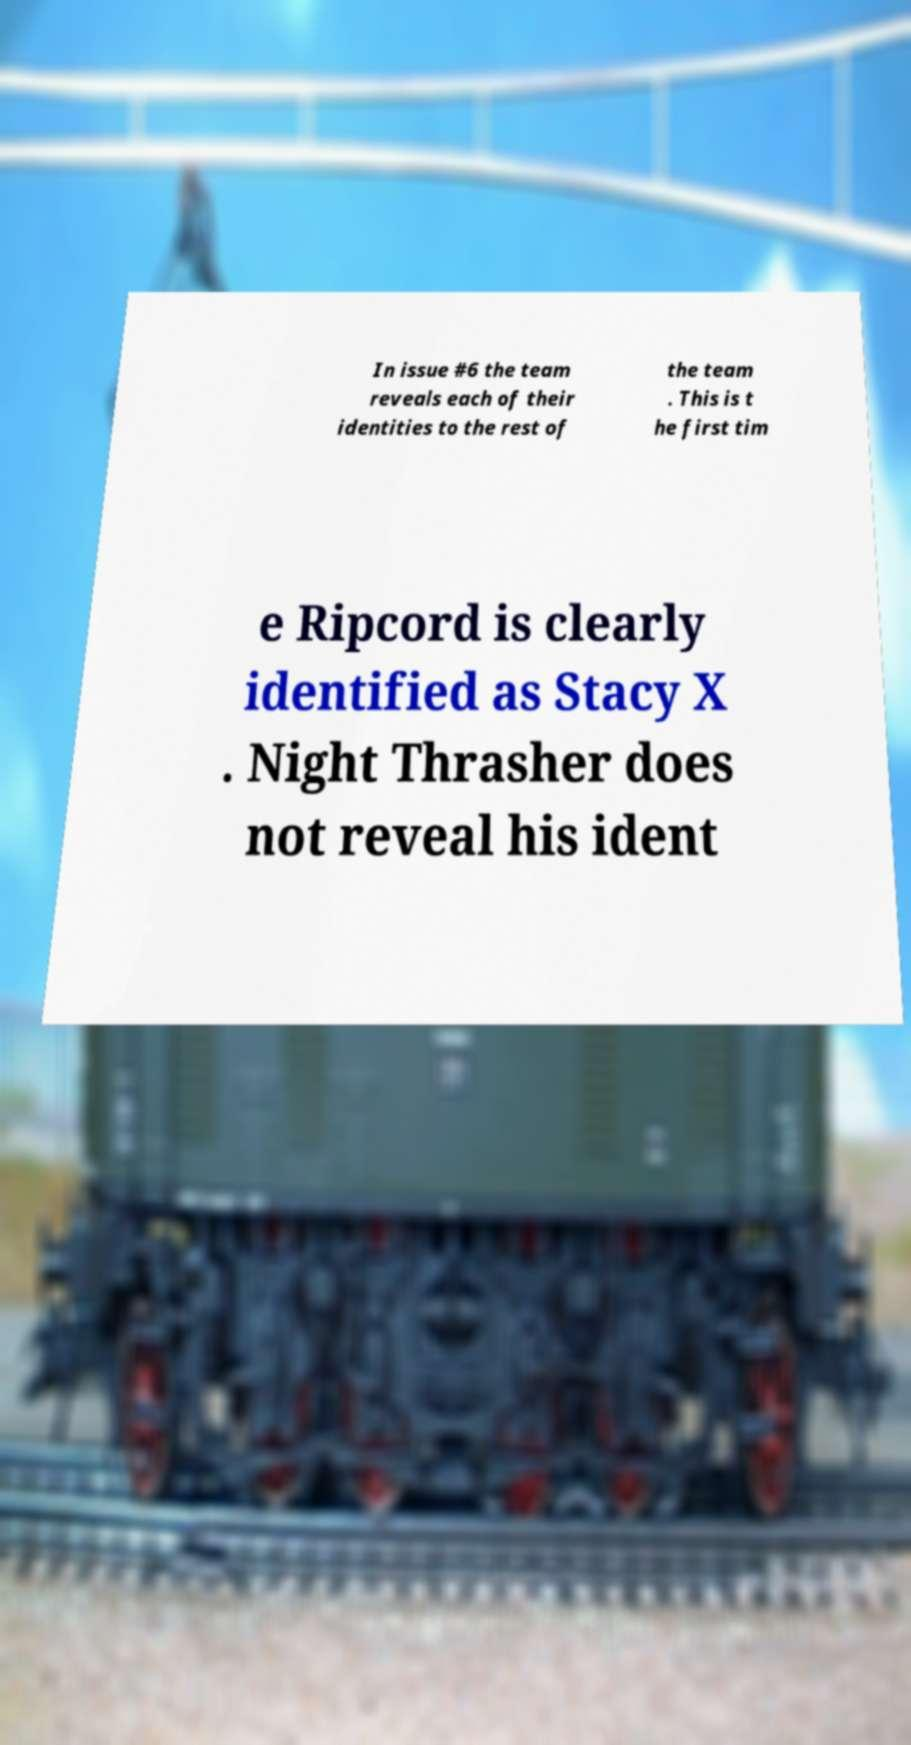Please read and relay the text visible in this image. What does it say? In issue #6 the team reveals each of their identities to the rest of the team . This is t he first tim e Ripcord is clearly identified as Stacy X . Night Thrasher does not reveal his ident 